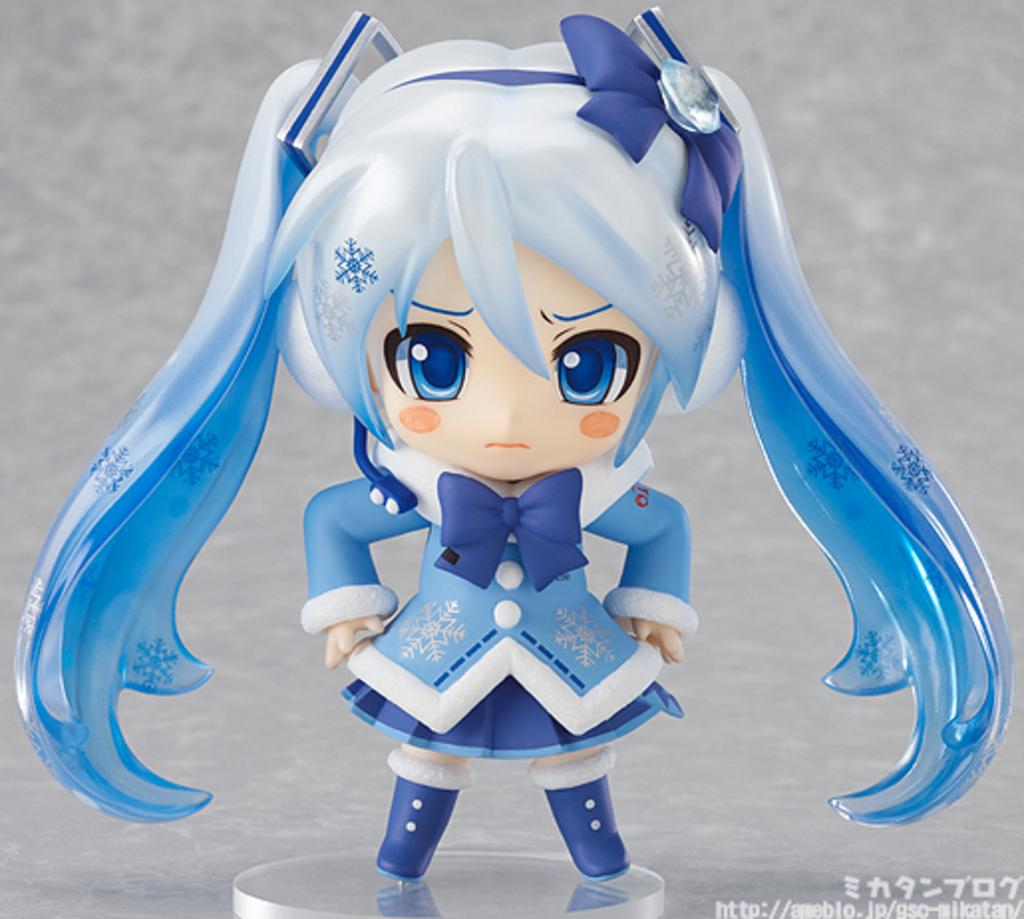What is the person in the image doing? The person is on a glass surface in the image. Can you describe any text visible in the image? There is text in the bottom right corner of the image. What system does the owner of the glass surface use to maintain its clarity? There is no information about a system or an owner in the image, so it cannot be determined. 